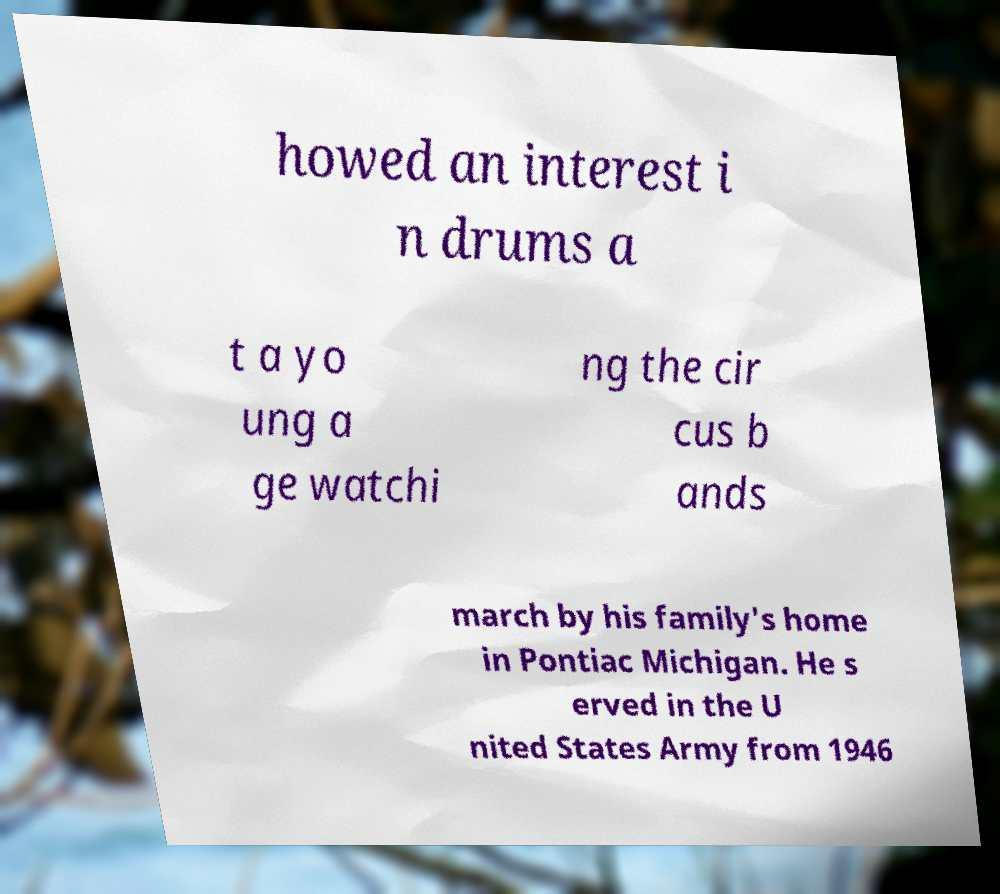Please identify and transcribe the text found in this image. howed an interest i n drums a t a yo ung a ge watchi ng the cir cus b ands march by his family's home in Pontiac Michigan. He s erved in the U nited States Army from 1946 